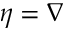<formula> <loc_0><loc_0><loc_500><loc_500>\eta = \nabla</formula> 